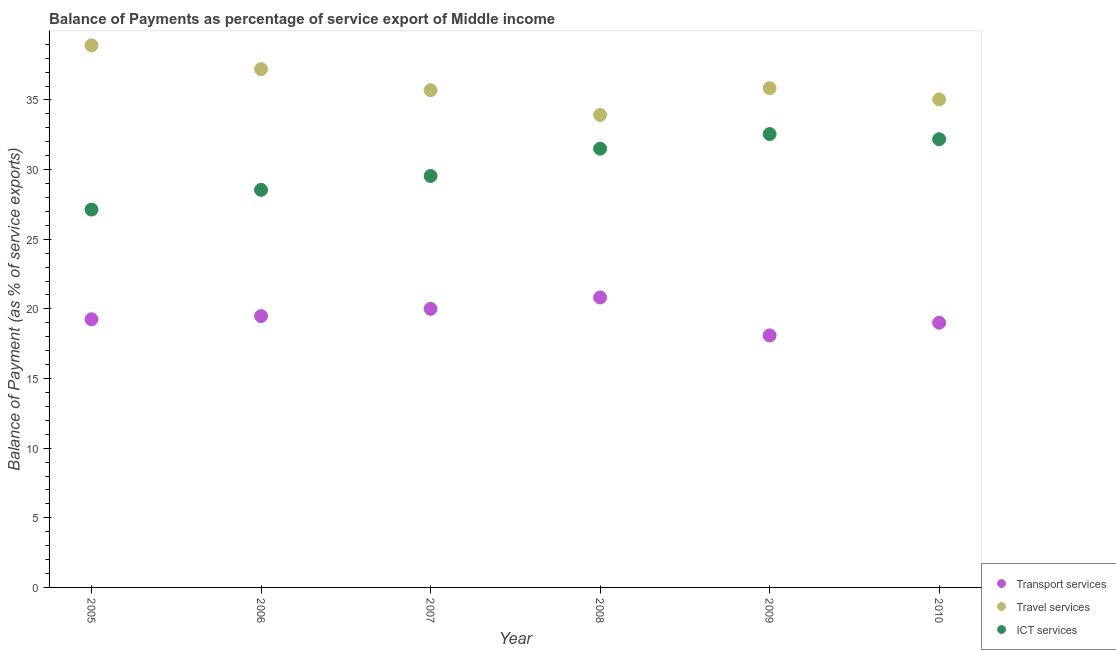How many different coloured dotlines are there?
Your answer should be compact. 3. Is the number of dotlines equal to the number of legend labels?
Your response must be concise. Yes. What is the balance of payment of travel services in 2007?
Ensure brevity in your answer.  35.7. Across all years, what is the maximum balance of payment of ict services?
Offer a terse response. 32.55. Across all years, what is the minimum balance of payment of ict services?
Keep it short and to the point. 27.13. In which year was the balance of payment of transport services maximum?
Your answer should be compact. 2008. In which year was the balance of payment of transport services minimum?
Ensure brevity in your answer.  2009. What is the total balance of payment of ict services in the graph?
Ensure brevity in your answer.  181.45. What is the difference between the balance of payment of transport services in 2007 and that in 2008?
Offer a terse response. -0.82. What is the difference between the balance of payment of travel services in 2009 and the balance of payment of ict services in 2005?
Give a very brief answer. 8.72. What is the average balance of payment of ict services per year?
Keep it short and to the point. 30.24. In the year 2006, what is the difference between the balance of payment of ict services and balance of payment of travel services?
Your answer should be compact. -8.67. In how many years, is the balance of payment of ict services greater than 26 %?
Make the answer very short. 6. What is the ratio of the balance of payment of travel services in 2006 to that in 2008?
Make the answer very short. 1.1. Is the balance of payment of ict services in 2005 less than that in 2007?
Your answer should be compact. Yes. What is the difference between the highest and the second highest balance of payment of travel services?
Offer a very short reply. 1.71. What is the difference between the highest and the lowest balance of payment of ict services?
Provide a succinct answer. 5.42. Is the sum of the balance of payment of transport services in 2007 and 2009 greater than the maximum balance of payment of ict services across all years?
Your answer should be very brief. Yes. Is it the case that in every year, the sum of the balance of payment of transport services and balance of payment of travel services is greater than the balance of payment of ict services?
Provide a short and direct response. Yes. Does the balance of payment of travel services monotonically increase over the years?
Provide a succinct answer. No. Is the balance of payment of travel services strictly greater than the balance of payment of ict services over the years?
Provide a short and direct response. Yes. Is the balance of payment of ict services strictly less than the balance of payment of travel services over the years?
Offer a terse response. Yes. How many dotlines are there?
Give a very brief answer. 3. How many years are there in the graph?
Your answer should be very brief. 6. What is the difference between two consecutive major ticks on the Y-axis?
Provide a short and direct response. 5. Are the values on the major ticks of Y-axis written in scientific E-notation?
Your answer should be compact. No. Does the graph contain any zero values?
Give a very brief answer. No. Does the graph contain grids?
Provide a short and direct response. No. Where does the legend appear in the graph?
Provide a short and direct response. Bottom right. How many legend labels are there?
Your answer should be compact. 3. How are the legend labels stacked?
Provide a succinct answer. Vertical. What is the title of the graph?
Provide a short and direct response. Balance of Payments as percentage of service export of Middle income. What is the label or title of the X-axis?
Provide a short and direct response. Year. What is the label or title of the Y-axis?
Offer a terse response. Balance of Payment (as % of service exports). What is the Balance of Payment (as % of service exports) of Transport services in 2005?
Ensure brevity in your answer.  19.25. What is the Balance of Payment (as % of service exports) in Travel services in 2005?
Offer a terse response. 38.92. What is the Balance of Payment (as % of service exports) in ICT services in 2005?
Make the answer very short. 27.13. What is the Balance of Payment (as % of service exports) in Transport services in 2006?
Offer a very short reply. 19.48. What is the Balance of Payment (as % of service exports) of Travel services in 2006?
Offer a very short reply. 37.21. What is the Balance of Payment (as % of service exports) in ICT services in 2006?
Provide a succinct answer. 28.54. What is the Balance of Payment (as % of service exports) in Transport services in 2007?
Ensure brevity in your answer.  20. What is the Balance of Payment (as % of service exports) of Travel services in 2007?
Keep it short and to the point. 35.7. What is the Balance of Payment (as % of service exports) of ICT services in 2007?
Keep it short and to the point. 29.54. What is the Balance of Payment (as % of service exports) of Transport services in 2008?
Your answer should be very brief. 20.82. What is the Balance of Payment (as % of service exports) in Travel services in 2008?
Offer a terse response. 33.92. What is the Balance of Payment (as % of service exports) in ICT services in 2008?
Give a very brief answer. 31.5. What is the Balance of Payment (as % of service exports) of Transport services in 2009?
Your answer should be very brief. 18.1. What is the Balance of Payment (as % of service exports) of Travel services in 2009?
Offer a very short reply. 35.84. What is the Balance of Payment (as % of service exports) of ICT services in 2009?
Ensure brevity in your answer.  32.55. What is the Balance of Payment (as % of service exports) in Transport services in 2010?
Provide a short and direct response. 19.01. What is the Balance of Payment (as % of service exports) in Travel services in 2010?
Offer a very short reply. 35.04. What is the Balance of Payment (as % of service exports) in ICT services in 2010?
Offer a very short reply. 32.18. Across all years, what is the maximum Balance of Payment (as % of service exports) of Transport services?
Make the answer very short. 20.82. Across all years, what is the maximum Balance of Payment (as % of service exports) of Travel services?
Make the answer very short. 38.92. Across all years, what is the maximum Balance of Payment (as % of service exports) of ICT services?
Your answer should be very brief. 32.55. Across all years, what is the minimum Balance of Payment (as % of service exports) of Transport services?
Give a very brief answer. 18.1. Across all years, what is the minimum Balance of Payment (as % of service exports) of Travel services?
Give a very brief answer. 33.92. Across all years, what is the minimum Balance of Payment (as % of service exports) in ICT services?
Your answer should be compact. 27.13. What is the total Balance of Payment (as % of service exports) in Transport services in the graph?
Your answer should be very brief. 116.65. What is the total Balance of Payment (as % of service exports) in Travel services in the graph?
Your answer should be compact. 216.64. What is the total Balance of Payment (as % of service exports) of ICT services in the graph?
Keep it short and to the point. 181.45. What is the difference between the Balance of Payment (as % of service exports) in Transport services in 2005 and that in 2006?
Make the answer very short. -0.23. What is the difference between the Balance of Payment (as % of service exports) of Travel services in 2005 and that in 2006?
Keep it short and to the point. 1.71. What is the difference between the Balance of Payment (as % of service exports) of ICT services in 2005 and that in 2006?
Give a very brief answer. -1.42. What is the difference between the Balance of Payment (as % of service exports) of Transport services in 2005 and that in 2007?
Provide a short and direct response. -0.75. What is the difference between the Balance of Payment (as % of service exports) in Travel services in 2005 and that in 2007?
Give a very brief answer. 3.22. What is the difference between the Balance of Payment (as % of service exports) of ICT services in 2005 and that in 2007?
Offer a terse response. -2.41. What is the difference between the Balance of Payment (as % of service exports) of Transport services in 2005 and that in 2008?
Your answer should be compact. -1.56. What is the difference between the Balance of Payment (as % of service exports) in Travel services in 2005 and that in 2008?
Make the answer very short. 5. What is the difference between the Balance of Payment (as % of service exports) in ICT services in 2005 and that in 2008?
Give a very brief answer. -4.38. What is the difference between the Balance of Payment (as % of service exports) of Transport services in 2005 and that in 2009?
Make the answer very short. 1.16. What is the difference between the Balance of Payment (as % of service exports) of Travel services in 2005 and that in 2009?
Provide a succinct answer. 3.08. What is the difference between the Balance of Payment (as % of service exports) in ICT services in 2005 and that in 2009?
Your answer should be very brief. -5.42. What is the difference between the Balance of Payment (as % of service exports) of Transport services in 2005 and that in 2010?
Your response must be concise. 0.25. What is the difference between the Balance of Payment (as % of service exports) of Travel services in 2005 and that in 2010?
Give a very brief answer. 3.88. What is the difference between the Balance of Payment (as % of service exports) in ICT services in 2005 and that in 2010?
Your response must be concise. -5.05. What is the difference between the Balance of Payment (as % of service exports) of Transport services in 2006 and that in 2007?
Your answer should be very brief. -0.52. What is the difference between the Balance of Payment (as % of service exports) of Travel services in 2006 and that in 2007?
Provide a short and direct response. 1.51. What is the difference between the Balance of Payment (as % of service exports) of ICT services in 2006 and that in 2007?
Provide a succinct answer. -1. What is the difference between the Balance of Payment (as % of service exports) in Transport services in 2006 and that in 2008?
Your response must be concise. -1.33. What is the difference between the Balance of Payment (as % of service exports) in Travel services in 2006 and that in 2008?
Offer a very short reply. 3.29. What is the difference between the Balance of Payment (as % of service exports) of ICT services in 2006 and that in 2008?
Make the answer very short. -2.96. What is the difference between the Balance of Payment (as % of service exports) in Transport services in 2006 and that in 2009?
Your answer should be very brief. 1.39. What is the difference between the Balance of Payment (as % of service exports) of Travel services in 2006 and that in 2009?
Your answer should be very brief. 1.37. What is the difference between the Balance of Payment (as % of service exports) of ICT services in 2006 and that in 2009?
Make the answer very short. -4.01. What is the difference between the Balance of Payment (as % of service exports) of Transport services in 2006 and that in 2010?
Offer a very short reply. 0.48. What is the difference between the Balance of Payment (as % of service exports) of Travel services in 2006 and that in 2010?
Ensure brevity in your answer.  2.17. What is the difference between the Balance of Payment (as % of service exports) in ICT services in 2006 and that in 2010?
Keep it short and to the point. -3.63. What is the difference between the Balance of Payment (as % of service exports) of Transport services in 2007 and that in 2008?
Provide a short and direct response. -0.82. What is the difference between the Balance of Payment (as % of service exports) in Travel services in 2007 and that in 2008?
Your answer should be compact. 1.78. What is the difference between the Balance of Payment (as % of service exports) of ICT services in 2007 and that in 2008?
Provide a short and direct response. -1.96. What is the difference between the Balance of Payment (as % of service exports) in Transport services in 2007 and that in 2009?
Provide a short and direct response. 1.91. What is the difference between the Balance of Payment (as % of service exports) of Travel services in 2007 and that in 2009?
Offer a very short reply. -0.14. What is the difference between the Balance of Payment (as % of service exports) of ICT services in 2007 and that in 2009?
Your response must be concise. -3.01. What is the difference between the Balance of Payment (as % of service exports) in Travel services in 2007 and that in 2010?
Your answer should be compact. 0.66. What is the difference between the Balance of Payment (as % of service exports) in ICT services in 2007 and that in 2010?
Your answer should be compact. -2.64. What is the difference between the Balance of Payment (as % of service exports) in Transport services in 2008 and that in 2009?
Make the answer very short. 2.72. What is the difference between the Balance of Payment (as % of service exports) of Travel services in 2008 and that in 2009?
Your response must be concise. -1.92. What is the difference between the Balance of Payment (as % of service exports) of ICT services in 2008 and that in 2009?
Ensure brevity in your answer.  -1.05. What is the difference between the Balance of Payment (as % of service exports) of Transport services in 2008 and that in 2010?
Offer a terse response. 1.81. What is the difference between the Balance of Payment (as % of service exports) in Travel services in 2008 and that in 2010?
Provide a succinct answer. -1.12. What is the difference between the Balance of Payment (as % of service exports) of ICT services in 2008 and that in 2010?
Keep it short and to the point. -0.67. What is the difference between the Balance of Payment (as % of service exports) of Transport services in 2009 and that in 2010?
Your answer should be very brief. -0.91. What is the difference between the Balance of Payment (as % of service exports) in Travel services in 2009 and that in 2010?
Offer a very short reply. 0.8. What is the difference between the Balance of Payment (as % of service exports) in ICT services in 2009 and that in 2010?
Offer a terse response. 0.37. What is the difference between the Balance of Payment (as % of service exports) of Transport services in 2005 and the Balance of Payment (as % of service exports) of Travel services in 2006?
Ensure brevity in your answer.  -17.96. What is the difference between the Balance of Payment (as % of service exports) of Transport services in 2005 and the Balance of Payment (as % of service exports) of ICT services in 2006?
Provide a succinct answer. -9.29. What is the difference between the Balance of Payment (as % of service exports) in Travel services in 2005 and the Balance of Payment (as % of service exports) in ICT services in 2006?
Make the answer very short. 10.38. What is the difference between the Balance of Payment (as % of service exports) in Transport services in 2005 and the Balance of Payment (as % of service exports) in Travel services in 2007?
Provide a short and direct response. -16.45. What is the difference between the Balance of Payment (as % of service exports) of Transport services in 2005 and the Balance of Payment (as % of service exports) of ICT services in 2007?
Offer a terse response. -10.29. What is the difference between the Balance of Payment (as % of service exports) of Travel services in 2005 and the Balance of Payment (as % of service exports) of ICT services in 2007?
Make the answer very short. 9.38. What is the difference between the Balance of Payment (as % of service exports) of Transport services in 2005 and the Balance of Payment (as % of service exports) of Travel services in 2008?
Make the answer very short. -14.67. What is the difference between the Balance of Payment (as % of service exports) of Transport services in 2005 and the Balance of Payment (as % of service exports) of ICT services in 2008?
Give a very brief answer. -12.25. What is the difference between the Balance of Payment (as % of service exports) in Travel services in 2005 and the Balance of Payment (as % of service exports) in ICT services in 2008?
Your answer should be compact. 7.42. What is the difference between the Balance of Payment (as % of service exports) in Transport services in 2005 and the Balance of Payment (as % of service exports) in Travel services in 2009?
Your answer should be very brief. -16.59. What is the difference between the Balance of Payment (as % of service exports) in Transport services in 2005 and the Balance of Payment (as % of service exports) in ICT services in 2009?
Provide a short and direct response. -13.3. What is the difference between the Balance of Payment (as % of service exports) in Travel services in 2005 and the Balance of Payment (as % of service exports) in ICT services in 2009?
Provide a short and direct response. 6.37. What is the difference between the Balance of Payment (as % of service exports) of Transport services in 2005 and the Balance of Payment (as % of service exports) of Travel services in 2010?
Give a very brief answer. -15.79. What is the difference between the Balance of Payment (as % of service exports) of Transport services in 2005 and the Balance of Payment (as % of service exports) of ICT services in 2010?
Give a very brief answer. -12.92. What is the difference between the Balance of Payment (as % of service exports) in Travel services in 2005 and the Balance of Payment (as % of service exports) in ICT services in 2010?
Keep it short and to the point. 6.74. What is the difference between the Balance of Payment (as % of service exports) of Transport services in 2006 and the Balance of Payment (as % of service exports) of Travel services in 2007?
Make the answer very short. -16.22. What is the difference between the Balance of Payment (as % of service exports) in Transport services in 2006 and the Balance of Payment (as % of service exports) in ICT services in 2007?
Keep it short and to the point. -10.06. What is the difference between the Balance of Payment (as % of service exports) in Travel services in 2006 and the Balance of Payment (as % of service exports) in ICT services in 2007?
Offer a very short reply. 7.67. What is the difference between the Balance of Payment (as % of service exports) in Transport services in 2006 and the Balance of Payment (as % of service exports) in Travel services in 2008?
Your answer should be compact. -14.44. What is the difference between the Balance of Payment (as % of service exports) of Transport services in 2006 and the Balance of Payment (as % of service exports) of ICT services in 2008?
Offer a terse response. -12.02. What is the difference between the Balance of Payment (as % of service exports) in Travel services in 2006 and the Balance of Payment (as % of service exports) in ICT services in 2008?
Make the answer very short. 5.71. What is the difference between the Balance of Payment (as % of service exports) of Transport services in 2006 and the Balance of Payment (as % of service exports) of Travel services in 2009?
Your answer should be very brief. -16.36. What is the difference between the Balance of Payment (as % of service exports) of Transport services in 2006 and the Balance of Payment (as % of service exports) of ICT services in 2009?
Your answer should be very brief. -13.07. What is the difference between the Balance of Payment (as % of service exports) of Travel services in 2006 and the Balance of Payment (as % of service exports) of ICT services in 2009?
Provide a short and direct response. 4.66. What is the difference between the Balance of Payment (as % of service exports) in Transport services in 2006 and the Balance of Payment (as % of service exports) in Travel services in 2010?
Offer a terse response. -15.56. What is the difference between the Balance of Payment (as % of service exports) in Transport services in 2006 and the Balance of Payment (as % of service exports) in ICT services in 2010?
Your answer should be very brief. -12.7. What is the difference between the Balance of Payment (as % of service exports) in Travel services in 2006 and the Balance of Payment (as % of service exports) in ICT services in 2010?
Keep it short and to the point. 5.04. What is the difference between the Balance of Payment (as % of service exports) of Transport services in 2007 and the Balance of Payment (as % of service exports) of Travel services in 2008?
Provide a short and direct response. -13.92. What is the difference between the Balance of Payment (as % of service exports) in Transport services in 2007 and the Balance of Payment (as % of service exports) in ICT services in 2008?
Provide a succinct answer. -11.5. What is the difference between the Balance of Payment (as % of service exports) in Travel services in 2007 and the Balance of Payment (as % of service exports) in ICT services in 2008?
Keep it short and to the point. 4.2. What is the difference between the Balance of Payment (as % of service exports) of Transport services in 2007 and the Balance of Payment (as % of service exports) of Travel services in 2009?
Your response must be concise. -15.84. What is the difference between the Balance of Payment (as % of service exports) in Transport services in 2007 and the Balance of Payment (as % of service exports) in ICT services in 2009?
Offer a terse response. -12.55. What is the difference between the Balance of Payment (as % of service exports) in Travel services in 2007 and the Balance of Payment (as % of service exports) in ICT services in 2009?
Give a very brief answer. 3.15. What is the difference between the Balance of Payment (as % of service exports) in Transport services in 2007 and the Balance of Payment (as % of service exports) in Travel services in 2010?
Your answer should be compact. -15.04. What is the difference between the Balance of Payment (as % of service exports) of Transport services in 2007 and the Balance of Payment (as % of service exports) of ICT services in 2010?
Make the answer very short. -12.18. What is the difference between the Balance of Payment (as % of service exports) of Travel services in 2007 and the Balance of Payment (as % of service exports) of ICT services in 2010?
Give a very brief answer. 3.52. What is the difference between the Balance of Payment (as % of service exports) in Transport services in 2008 and the Balance of Payment (as % of service exports) in Travel services in 2009?
Offer a terse response. -15.03. What is the difference between the Balance of Payment (as % of service exports) in Transport services in 2008 and the Balance of Payment (as % of service exports) in ICT services in 2009?
Your response must be concise. -11.73. What is the difference between the Balance of Payment (as % of service exports) in Travel services in 2008 and the Balance of Payment (as % of service exports) in ICT services in 2009?
Offer a very short reply. 1.37. What is the difference between the Balance of Payment (as % of service exports) of Transport services in 2008 and the Balance of Payment (as % of service exports) of Travel services in 2010?
Give a very brief answer. -14.22. What is the difference between the Balance of Payment (as % of service exports) in Transport services in 2008 and the Balance of Payment (as % of service exports) in ICT services in 2010?
Your answer should be compact. -11.36. What is the difference between the Balance of Payment (as % of service exports) in Travel services in 2008 and the Balance of Payment (as % of service exports) in ICT services in 2010?
Give a very brief answer. 1.74. What is the difference between the Balance of Payment (as % of service exports) of Transport services in 2009 and the Balance of Payment (as % of service exports) of Travel services in 2010?
Keep it short and to the point. -16.94. What is the difference between the Balance of Payment (as % of service exports) of Transport services in 2009 and the Balance of Payment (as % of service exports) of ICT services in 2010?
Your answer should be very brief. -14.08. What is the difference between the Balance of Payment (as % of service exports) of Travel services in 2009 and the Balance of Payment (as % of service exports) of ICT services in 2010?
Make the answer very short. 3.66. What is the average Balance of Payment (as % of service exports) in Transport services per year?
Provide a succinct answer. 19.44. What is the average Balance of Payment (as % of service exports) of Travel services per year?
Your answer should be very brief. 36.11. What is the average Balance of Payment (as % of service exports) in ICT services per year?
Offer a terse response. 30.24. In the year 2005, what is the difference between the Balance of Payment (as % of service exports) of Transport services and Balance of Payment (as % of service exports) of Travel services?
Offer a very short reply. -19.67. In the year 2005, what is the difference between the Balance of Payment (as % of service exports) in Transport services and Balance of Payment (as % of service exports) in ICT services?
Offer a terse response. -7.87. In the year 2005, what is the difference between the Balance of Payment (as % of service exports) of Travel services and Balance of Payment (as % of service exports) of ICT services?
Ensure brevity in your answer.  11.79. In the year 2006, what is the difference between the Balance of Payment (as % of service exports) in Transport services and Balance of Payment (as % of service exports) in Travel services?
Give a very brief answer. -17.73. In the year 2006, what is the difference between the Balance of Payment (as % of service exports) of Transport services and Balance of Payment (as % of service exports) of ICT services?
Provide a succinct answer. -9.06. In the year 2006, what is the difference between the Balance of Payment (as % of service exports) of Travel services and Balance of Payment (as % of service exports) of ICT services?
Ensure brevity in your answer.  8.67. In the year 2007, what is the difference between the Balance of Payment (as % of service exports) of Transport services and Balance of Payment (as % of service exports) of Travel services?
Give a very brief answer. -15.7. In the year 2007, what is the difference between the Balance of Payment (as % of service exports) of Transport services and Balance of Payment (as % of service exports) of ICT services?
Give a very brief answer. -9.54. In the year 2007, what is the difference between the Balance of Payment (as % of service exports) of Travel services and Balance of Payment (as % of service exports) of ICT services?
Offer a very short reply. 6.16. In the year 2008, what is the difference between the Balance of Payment (as % of service exports) in Transport services and Balance of Payment (as % of service exports) in Travel services?
Keep it short and to the point. -13.11. In the year 2008, what is the difference between the Balance of Payment (as % of service exports) in Transport services and Balance of Payment (as % of service exports) in ICT services?
Offer a very short reply. -10.69. In the year 2008, what is the difference between the Balance of Payment (as % of service exports) in Travel services and Balance of Payment (as % of service exports) in ICT services?
Your response must be concise. 2.42. In the year 2009, what is the difference between the Balance of Payment (as % of service exports) of Transport services and Balance of Payment (as % of service exports) of Travel services?
Provide a short and direct response. -17.75. In the year 2009, what is the difference between the Balance of Payment (as % of service exports) of Transport services and Balance of Payment (as % of service exports) of ICT services?
Give a very brief answer. -14.45. In the year 2009, what is the difference between the Balance of Payment (as % of service exports) in Travel services and Balance of Payment (as % of service exports) in ICT services?
Your answer should be compact. 3.29. In the year 2010, what is the difference between the Balance of Payment (as % of service exports) of Transport services and Balance of Payment (as % of service exports) of Travel services?
Keep it short and to the point. -16.03. In the year 2010, what is the difference between the Balance of Payment (as % of service exports) of Transport services and Balance of Payment (as % of service exports) of ICT services?
Make the answer very short. -13.17. In the year 2010, what is the difference between the Balance of Payment (as % of service exports) in Travel services and Balance of Payment (as % of service exports) in ICT services?
Offer a terse response. 2.86. What is the ratio of the Balance of Payment (as % of service exports) of Transport services in 2005 to that in 2006?
Your response must be concise. 0.99. What is the ratio of the Balance of Payment (as % of service exports) of Travel services in 2005 to that in 2006?
Keep it short and to the point. 1.05. What is the ratio of the Balance of Payment (as % of service exports) of ICT services in 2005 to that in 2006?
Provide a short and direct response. 0.95. What is the ratio of the Balance of Payment (as % of service exports) of Transport services in 2005 to that in 2007?
Make the answer very short. 0.96. What is the ratio of the Balance of Payment (as % of service exports) in Travel services in 2005 to that in 2007?
Ensure brevity in your answer.  1.09. What is the ratio of the Balance of Payment (as % of service exports) of ICT services in 2005 to that in 2007?
Your answer should be compact. 0.92. What is the ratio of the Balance of Payment (as % of service exports) in Transport services in 2005 to that in 2008?
Provide a succinct answer. 0.93. What is the ratio of the Balance of Payment (as % of service exports) of Travel services in 2005 to that in 2008?
Provide a succinct answer. 1.15. What is the ratio of the Balance of Payment (as % of service exports) of ICT services in 2005 to that in 2008?
Give a very brief answer. 0.86. What is the ratio of the Balance of Payment (as % of service exports) in Transport services in 2005 to that in 2009?
Ensure brevity in your answer.  1.06. What is the ratio of the Balance of Payment (as % of service exports) of Travel services in 2005 to that in 2009?
Make the answer very short. 1.09. What is the ratio of the Balance of Payment (as % of service exports) in ICT services in 2005 to that in 2009?
Give a very brief answer. 0.83. What is the ratio of the Balance of Payment (as % of service exports) of Transport services in 2005 to that in 2010?
Make the answer very short. 1.01. What is the ratio of the Balance of Payment (as % of service exports) in Travel services in 2005 to that in 2010?
Provide a succinct answer. 1.11. What is the ratio of the Balance of Payment (as % of service exports) in ICT services in 2005 to that in 2010?
Make the answer very short. 0.84. What is the ratio of the Balance of Payment (as % of service exports) of Travel services in 2006 to that in 2007?
Keep it short and to the point. 1.04. What is the ratio of the Balance of Payment (as % of service exports) of ICT services in 2006 to that in 2007?
Make the answer very short. 0.97. What is the ratio of the Balance of Payment (as % of service exports) of Transport services in 2006 to that in 2008?
Keep it short and to the point. 0.94. What is the ratio of the Balance of Payment (as % of service exports) of Travel services in 2006 to that in 2008?
Give a very brief answer. 1.1. What is the ratio of the Balance of Payment (as % of service exports) in ICT services in 2006 to that in 2008?
Offer a terse response. 0.91. What is the ratio of the Balance of Payment (as % of service exports) of Transport services in 2006 to that in 2009?
Keep it short and to the point. 1.08. What is the ratio of the Balance of Payment (as % of service exports) of Travel services in 2006 to that in 2009?
Offer a terse response. 1.04. What is the ratio of the Balance of Payment (as % of service exports) of ICT services in 2006 to that in 2009?
Your answer should be compact. 0.88. What is the ratio of the Balance of Payment (as % of service exports) of Transport services in 2006 to that in 2010?
Give a very brief answer. 1.02. What is the ratio of the Balance of Payment (as % of service exports) of Travel services in 2006 to that in 2010?
Ensure brevity in your answer.  1.06. What is the ratio of the Balance of Payment (as % of service exports) in ICT services in 2006 to that in 2010?
Ensure brevity in your answer.  0.89. What is the ratio of the Balance of Payment (as % of service exports) of Transport services in 2007 to that in 2008?
Offer a very short reply. 0.96. What is the ratio of the Balance of Payment (as % of service exports) in Travel services in 2007 to that in 2008?
Give a very brief answer. 1.05. What is the ratio of the Balance of Payment (as % of service exports) in ICT services in 2007 to that in 2008?
Provide a succinct answer. 0.94. What is the ratio of the Balance of Payment (as % of service exports) in Transport services in 2007 to that in 2009?
Offer a terse response. 1.11. What is the ratio of the Balance of Payment (as % of service exports) of Travel services in 2007 to that in 2009?
Your answer should be compact. 1. What is the ratio of the Balance of Payment (as % of service exports) of ICT services in 2007 to that in 2009?
Your answer should be compact. 0.91. What is the ratio of the Balance of Payment (as % of service exports) in Transport services in 2007 to that in 2010?
Give a very brief answer. 1.05. What is the ratio of the Balance of Payment (as % of service exports) of Travel services in 2007 to that in 2010?
Your answer should be compact. 1.02. What is the ratio of the Balance of Payment (as % of service exports) of ICT services in 2007 to that in 2010?
Make the answer very short. 0.92. What is the ratio of the Balance of Payment (as % of service exports) of Transport services in 2008 to that in 2009?
Provide a succinct answer. 1.15. What is the ratio of the Balance of Payment (as % of service exports) of Travel services in 2008 to that in 2009?
Keep it short and to the point. 0.95. What is the ratio of the Balance of Payment (as % of service exports) in ICT services in 2008 to that in 2009?
Keep it short and to the point. 0.97. What is the ratio of the Balance of Payment (as % of service exports) of Transport services in 2008 to that in 2010?
Make the answer very short. 1.1. What is the ratio of the Balance of Payment (as % of service exports) in Travel services in 2008 to that in 2010?
Provide a succinct answer. 0.97. What is the ratio of the Balance of Payment (as % of service exports) in ICT services in 2008 to that in 2010?
Make the answer very short. 0.98. What is the ratio of the Balance of Payment (as % of service exports) in Transport services in 2009 to that in 2010?
Your answer should be very brief. 0.95. What is the ratio of the Balance of Payment (as % of service exports) of Travel services in 2009 to that in 2010?
Provide a succinct answer. 1.02. What is the ratio of the Balance of Payment (as % of service exports) in ICT services in 2009 to that in 2010?
Your answer should be very brief. 1.01. What is the difference between the highest and the second highest Balance of Payment (as % of service exports) in Transport services?
Your response must be concise. 0.82. What is the difference between the highest and the second highest Balance of Payment (as % of service exports) in Travel services?
Offer a very short reply. 1.71. What is the difference between the highest and the second highest Balance of Payment (as % of service exports) of ICT services?
Your answer should be very brief. 0.37. What is the difference between the highest and the lowest Balance of Payment (as % of service exports) of Transport services?
Keep it short and to the point. 2.72. What is the difference between the highest and the lowest Balance of Payment (as % of service exports) in Travel services?
Keep it short and to the point. 5. What is the difference between the highest and the lowest Balance of Payment (as % of service exports) of ICT services?
Your answer should be compact. 5.42. 